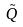<formula> <loc_0><loc_0><loc_500><loc_500>\tilde { Q }</formula> 